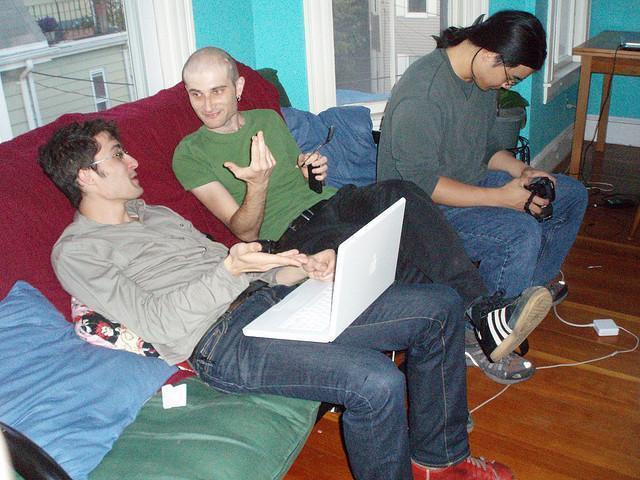How many people are visible?
Give a very brief answer. 3. 